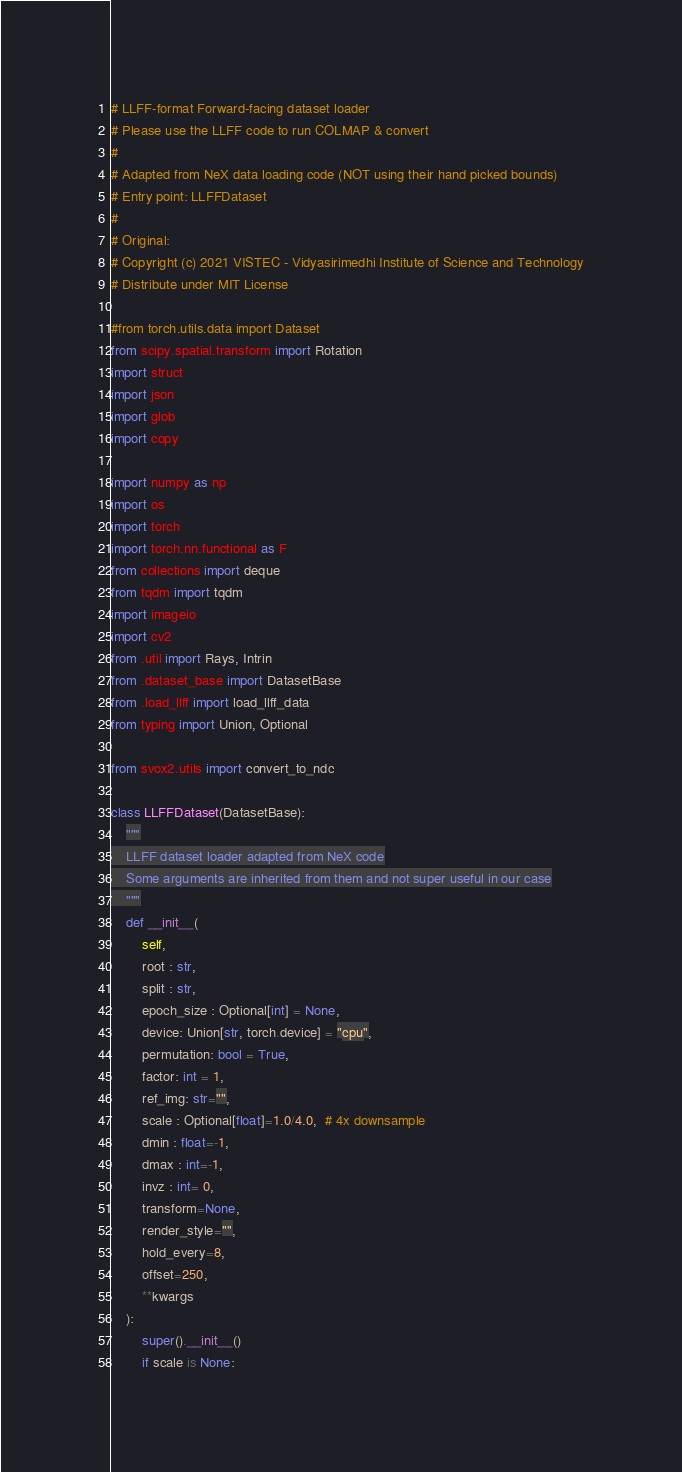<code> <loc_0><loc_0><loc_500><loc_500><_Python_># LLFF-format Forward-facing dataset loader
# Please use the LLFF code to run COLMAP & convert 
#
# Adapted from NeX data loading code (NOT using their hand picked bounds)
# Entry point: LLFFDataset
#
# Original:
# Copyright (c) 2021 VISTEC - Vidyasirimedhi Institute of Science and Technology
# Distribute under MIT License

#from torch.utils.data import Dataset
from scipy.spatial.transform import Rotation
import struct
import json
import glob
import copy

import numpy as np
import os
import torch
import torch.nn.functional as F
from collections import deque
from tqdm import tqdm
import imageio
import cv2
from .util import Rays, Intrin
from .dataset_base import DatasetBase
from .load_llff import load_llff_data
from typing import Union, Optional

from svox2.utils import convert_to_ndc

class LLFFDataset(DatasetBase):
    """
    LLFF dataset loader adapted from NeX code
    Some arguments are inherited from them and not super useful in our case
    """
    def __init__(
        self,
        root : str,
        split : str,
        epoch_size : Optional[int] = None,
        device: Union[str, torch.device] = "cpu",
        permutation: bool = True,
        factor: int = 1,
        ref_img: str="",
        scale : Optional[float]=1.0/4.0,  # 4x downsample
        dmin : float=-1,
        dmax : int=-1,
        invz : int= 0,
        transform=None,
        render_style="",
        hold_every=8,
        offset=250,
        **kwargs
    ):
        super().__init__()
        if scale is None:</code> 